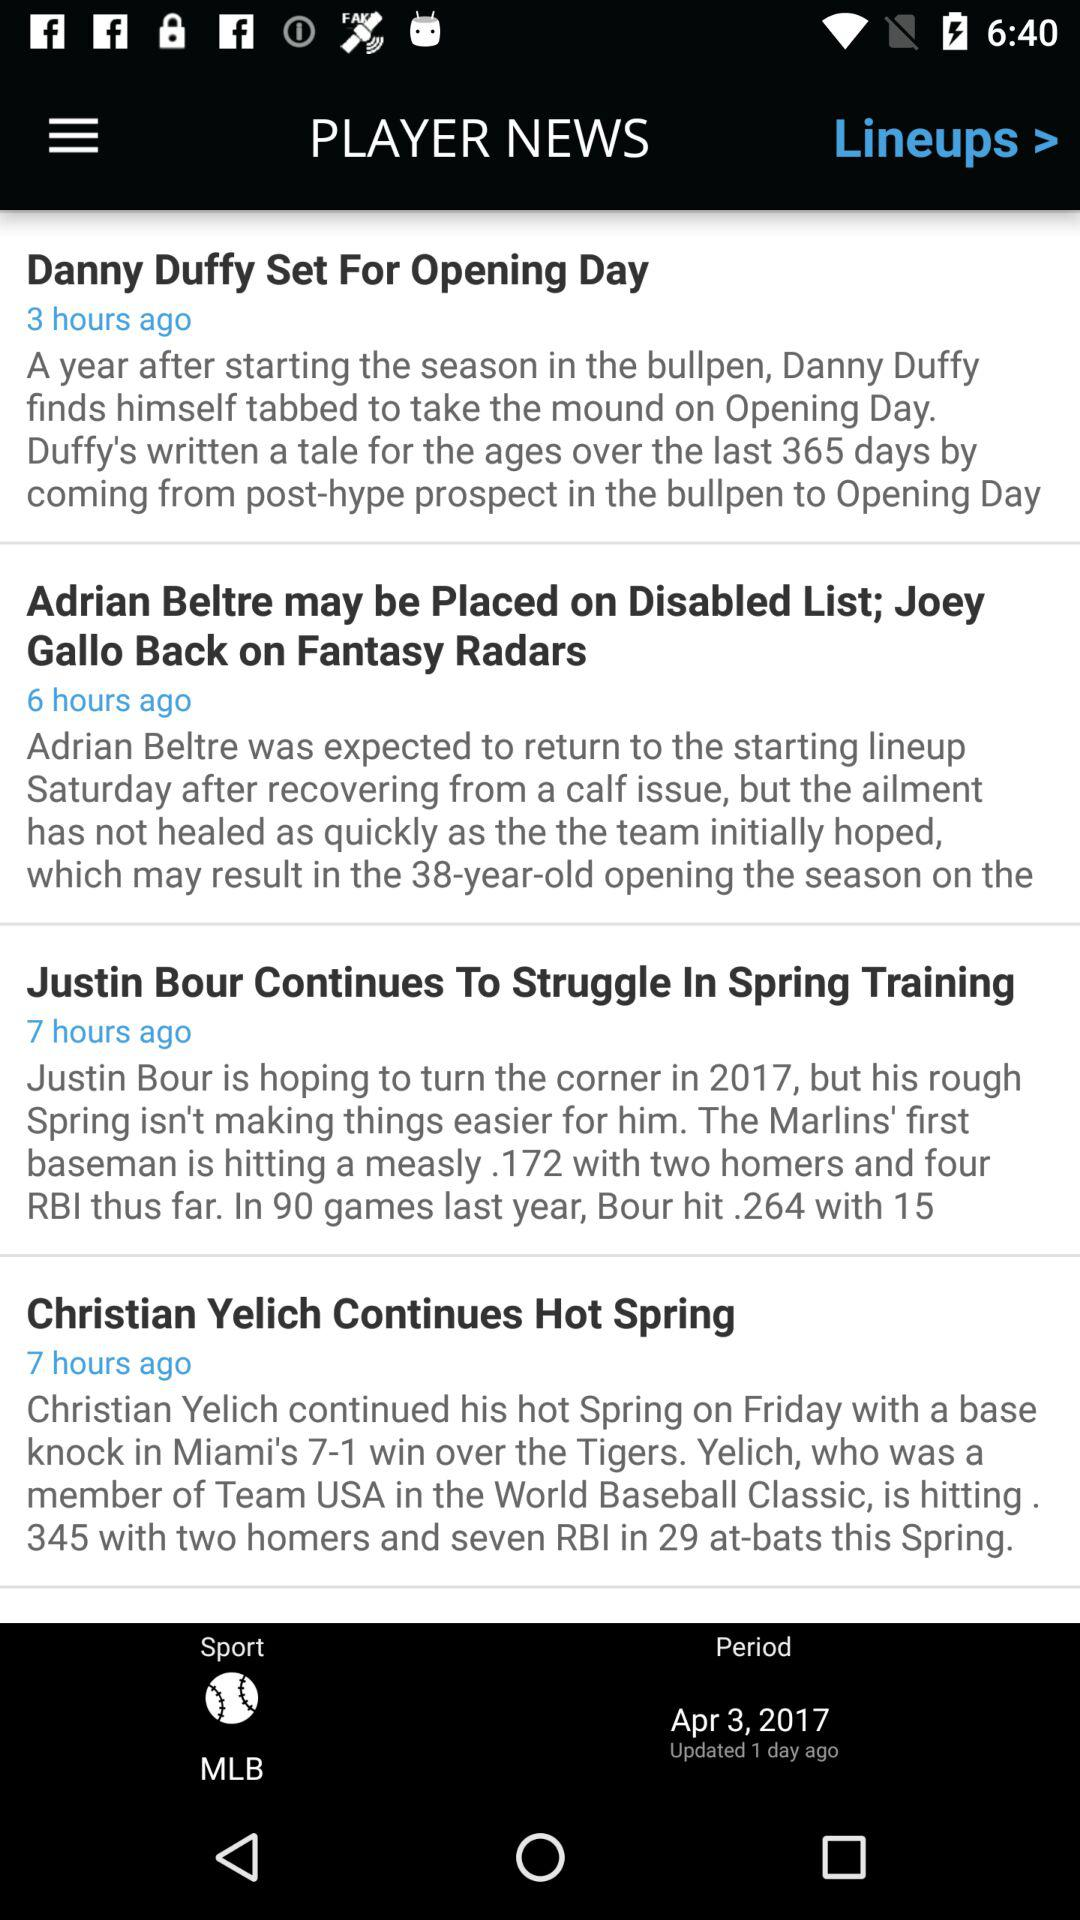What is the sport name? The sport name is MLB. 